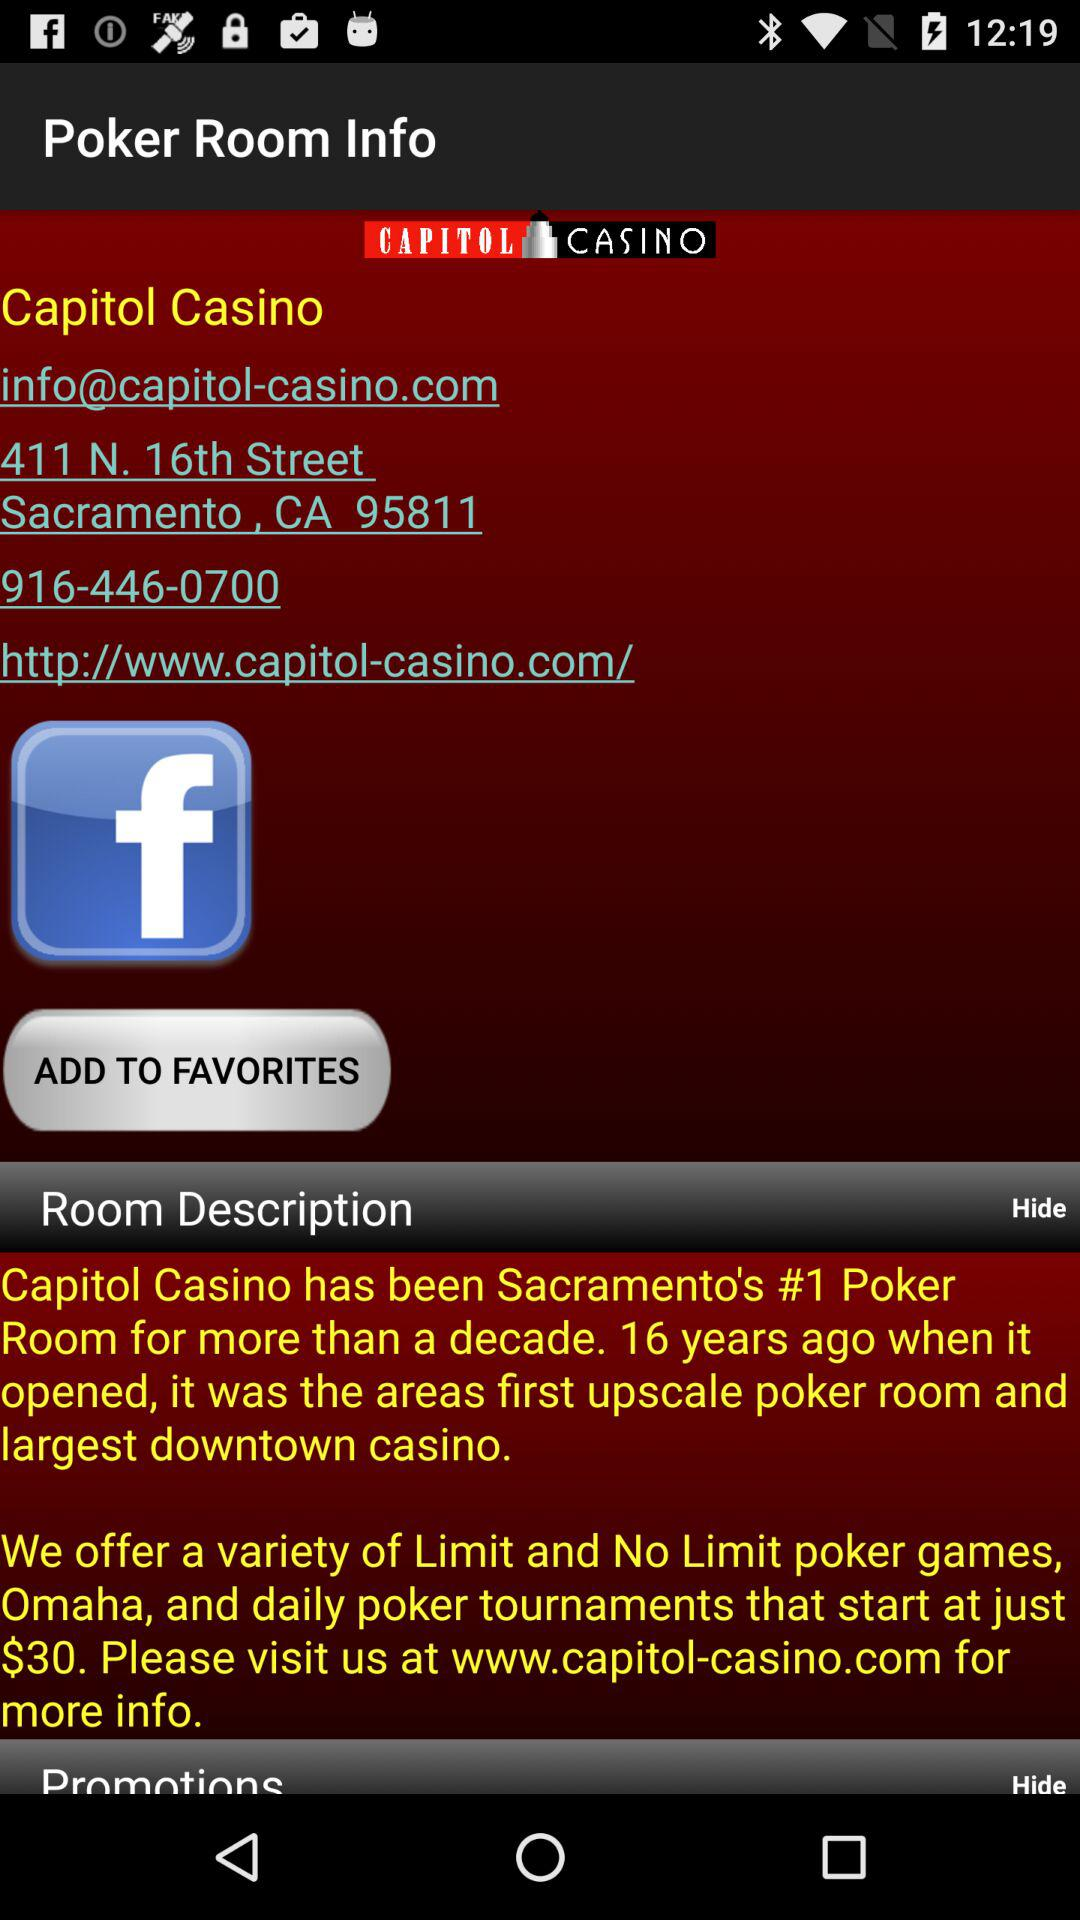What is the name of the casino? The name of the casino is "Capitol". 